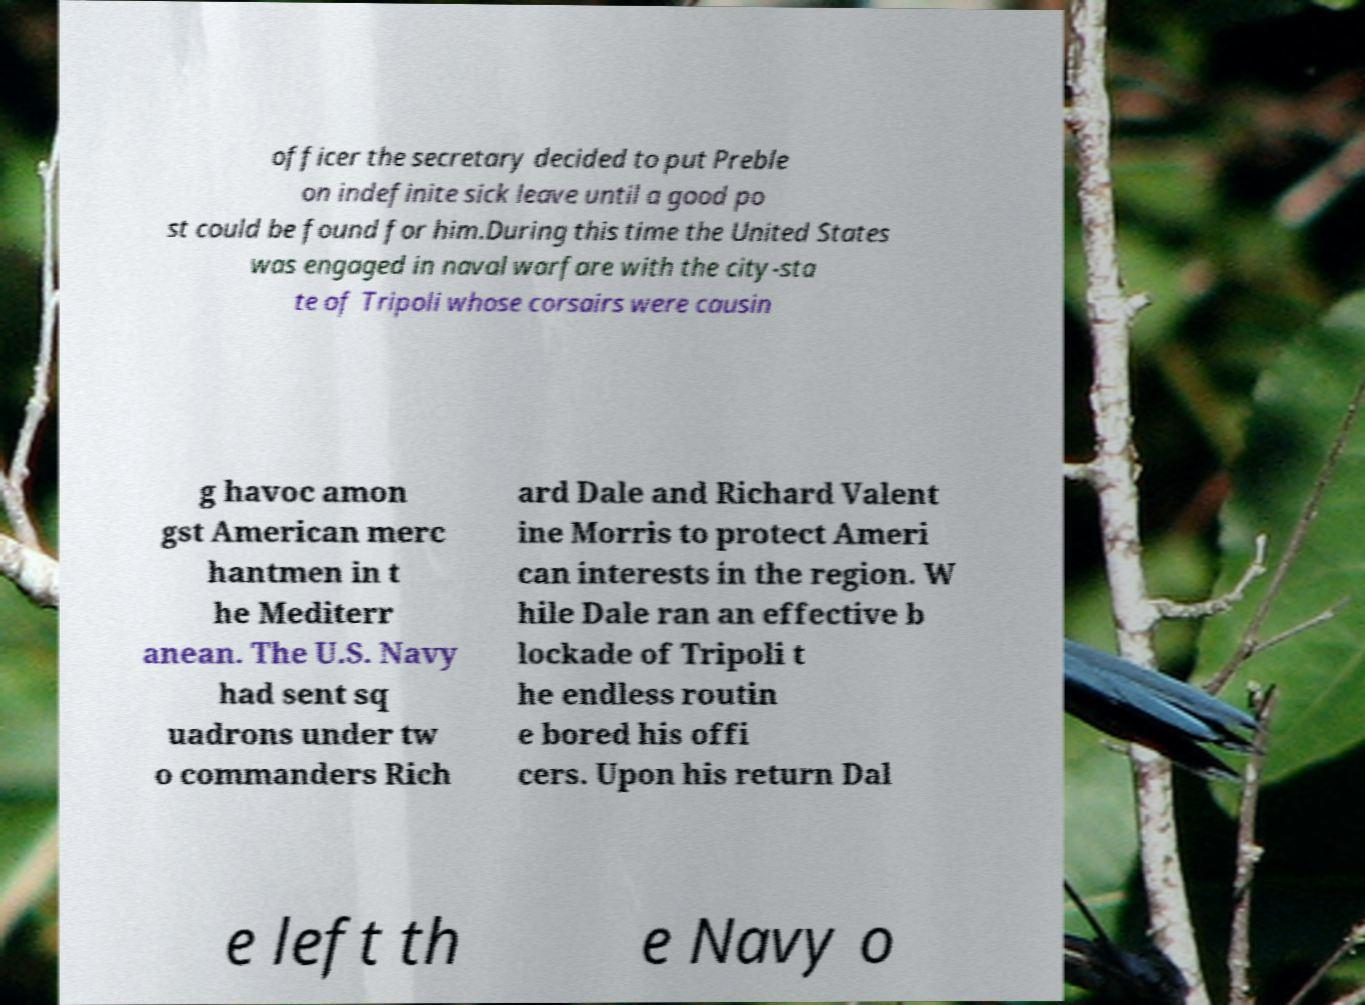Please identify and transcribe the text found in this image. officer the secretary decided to put Preble on indefinite sick leave until a good po st could be found for him.During this time the United States was engaged in naval warfare with the city-sta te of Tripoli whose corsairs were causin g havoc amon gst American merc hantmen in t he Mediterr anean. The U.S. Navy had sent sq uadrons under tw o commanders Rich ard Dale and Richard Valent ine Morris to protect Ameri can interests in the region. W hile Dale ran an effective b lockade of Tripoli t he endless routin e bored his offi cers. Upon his return Dal e left th e Navy o 